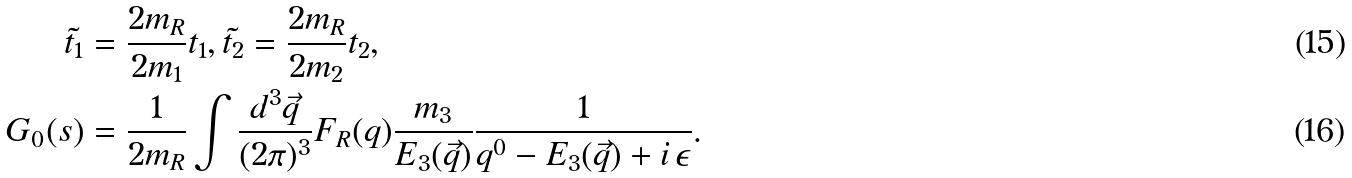Convert formula to latex. <formula><loc_0><loc_0><loc_500><loc_500>\tilde { t _ { 1 } } & = \frac { 2 m _ { R } } { 2 m _ { 1 } } t _ { 1 } , \tilde { t _ { 2 } } = \frac { 2 m _ { R } } { 2 m _ { 2 } } t _ { 2 } , \\ G _ { 0 } ( s ) & = \frac { 1 } { 2 m _ { R } } \int \frac { d ^ { 3 } \vec { q } } { ( 2 \pi ) ^ { 3 } } F _ { R } ( q ) \frac { m _ { 3 } } { E _ { 3 } ( \vec { q } ) } \frac { 1 } { q ^ { 0 } - E _ { 3 } ( \vec { q } ) + i \, \epsilon } .</formula> 